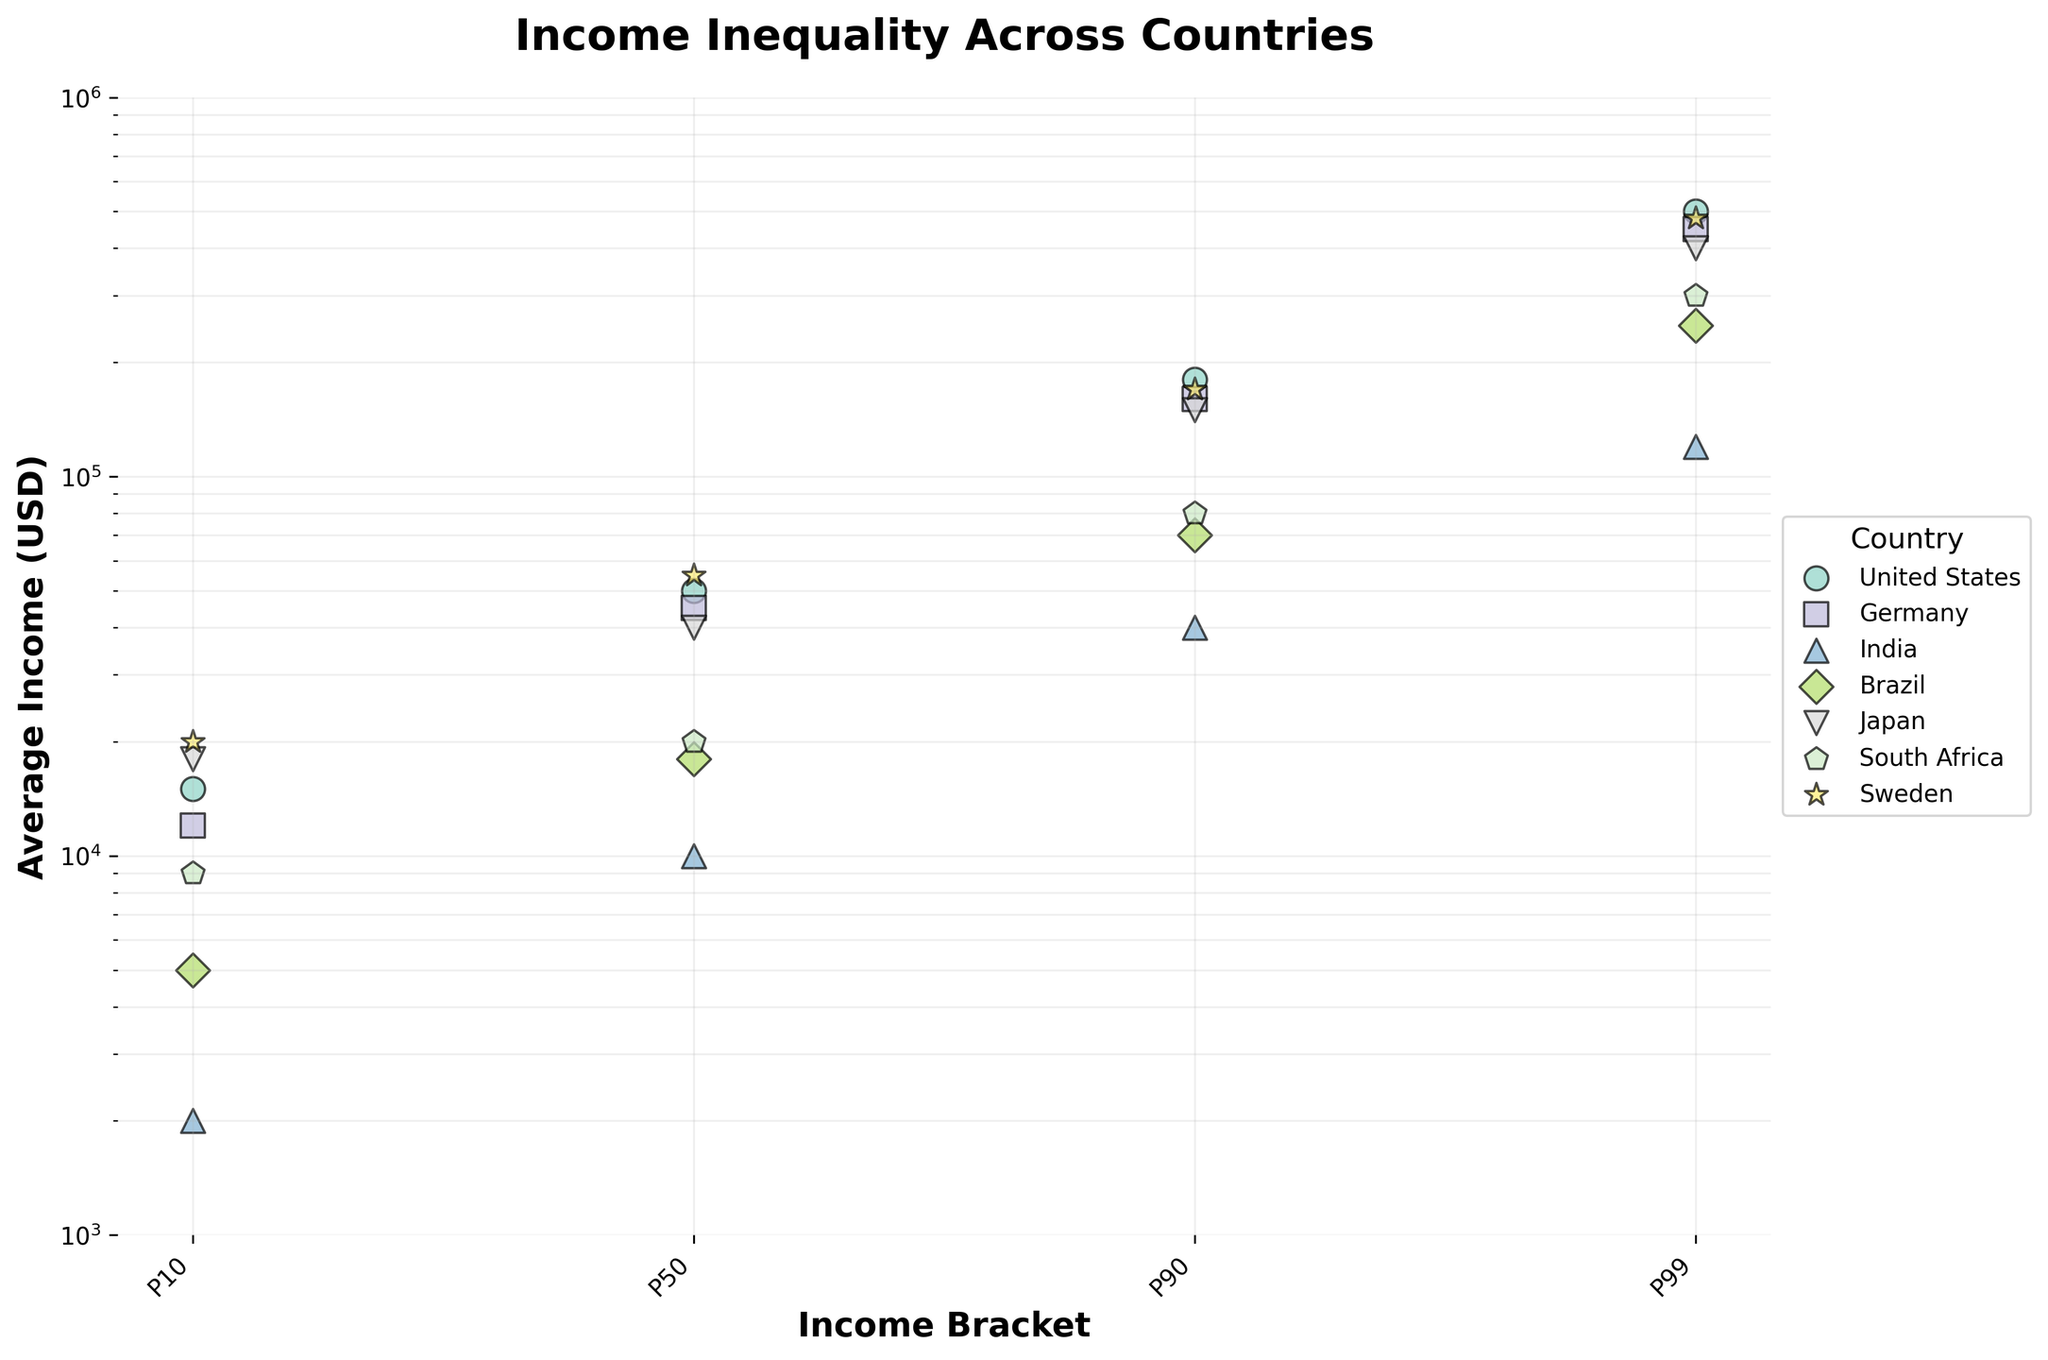Which country has the highest average income in the P99 income bracket? The P99 income bracket represents the 99th percentile of income earners in each country. By looking at the highest values within the P99 category, it's clear that the United States has the highest average income at 500,000 USD.
Answer: United States What is the median average income for Germany across all income brackets? Germany's average incomes for P10, P50, P90, and P99 are 12,000, 45,000, 160,000, and 450,000 USD respectively. When sorted: 12,000, 45,000, 160,000, and 450,000, the median is the average of the two middle values (45,000 and 160,000), resulting in (45,000 + 160,000)/2 = 102,500 USD.
Answer: 102,500 USD Which country shows the least disparity between P10 and P99 income brackets? The disparity is measured by the difference between the P10 and P99 average incomes. Calculating this for all countries: United States (500,000 - 15,000 = 485,000), Germany (450,000 - 12,000 = 438,000), India (120,000 - 2,000 = 118,000), Brazil (250,000 - 5,000 = 245,000), Japan (400,000 - 18,000 = 382,000), South Africa (300,000 - 9,000 = 291,000), Sweden (480,000 - 20,000 = 460,000). Therefore, India has the least disparity at 118,000 USD.
Answer: India How does the average income of P50 in Japan compare to P50 in Brazil? By comparing the average incomes in the P50 bracket, Japan has an income of 40,000 USD, and Brazil has an income of 18,000 USD. Thus, Japan's P50 average income is higher than Brazil's.
Answer: Japan's is higher What is the range of average incomes for Sweden across all income brackets? The range is the difference between the maximum and minimum values among the average incomes. For Sweden, the values are 20,000, 55,000, 170,000, and 480,000 USD. The range is 480,000 - 20,000 = 460,000 USD.
Answer: 460,000 USD Which country has the highest average income in the P90 income bracket, and what is its value? Looking at the P90 values for all countries: United States (180,000), Germany (160,000), India (40,000), Brazil (70,000), Japan (150,000), South Africa (80,000), and Sweden (170,000). The highest is the United States at 180,000 USD.
Answer: United States, 180,000 USD What is the average income difference between the P90 and P10 brackets in Brazil? For Brazil, the P90 and P10 average incomes are 70,000 and 5,000 USD respectively. The difference is 70,000 - 5,000 = 65,000 USD.
Answer: 65,000 USD How does the income bracket distribution in India compare to Sweden, considering both the lowest and highest average incomes? India's lowest and highest incomes are 2,000 (P10) and 120,000 USD (P99). Sweden's lowest and highest incomes are 20,000 (P10) and 480,000 USD (P99). Sweden's income levels are significantly higher than India's at both extremes (P10 and P99).
Answer: Sweden's incomes are higher Which country has the second highest average income in the P50 bracket? The average incomes in the P50 bracket for all countries are: United States (50,000), Germany (45,000), India (10,000), Brazil (18,000), Japan (40,000), South Africa (20,000), Sweden (55,000). The second highest is the United States at 50,000 USD.
Answer: United States What is the overall trend in income inequality observed in the plotted data? Examining the differences between income brackets for each country, it appears that high-income countries like the United States, Sweden, and Germany exhibit greater disparities between the lowest and highest income brackets, while lower-income countries like India and Brazil have smaller disparities. South Africa shows moderate disparity. This suggests higher income inequality in wealthier countries.
Answer: Higher income countries show greater income inequality 